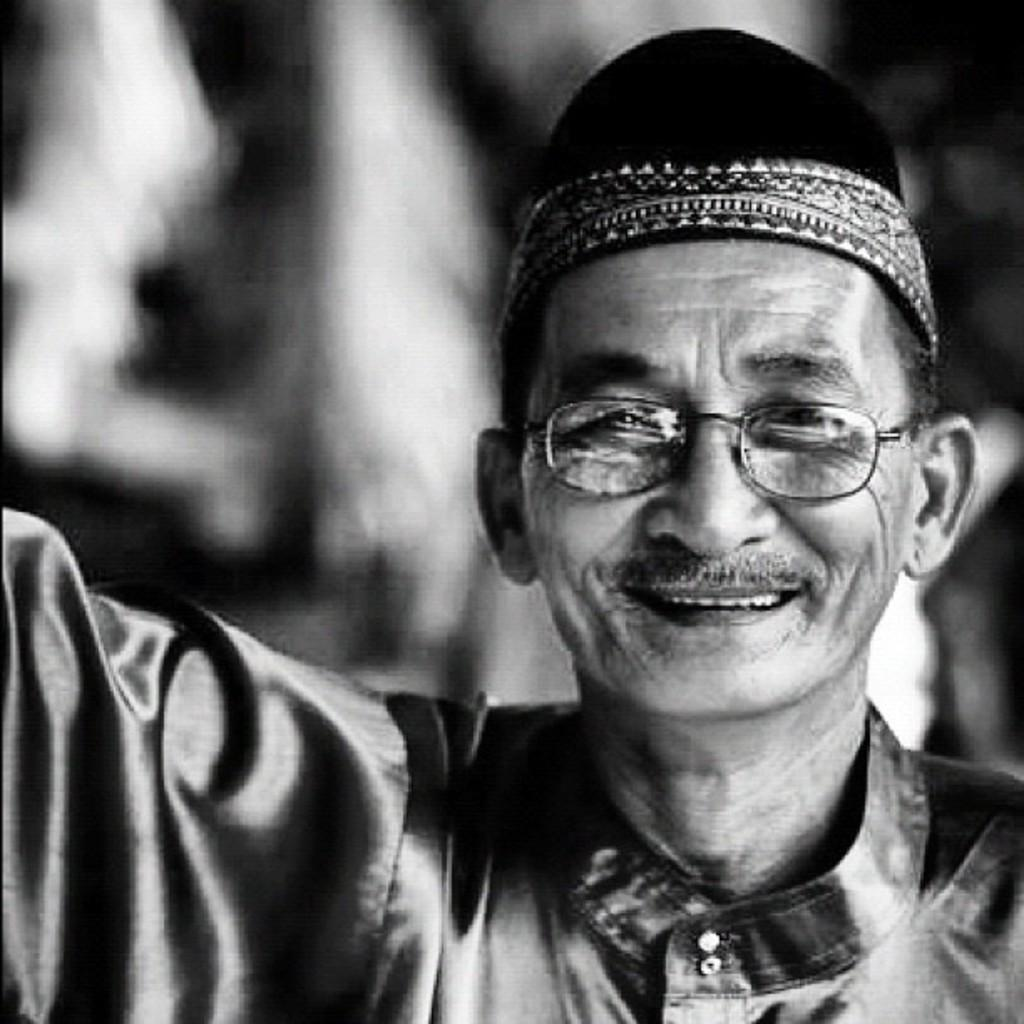Who is present in the image? There is a man in the image. On which side of the image is the man located? The man is on the right side of the image. What accessories is the man wearing? The man is wearing spectacles and a cap. What adjustments is the servant making to the man's cap in the image? There is no servant present in the image, and the man is not making any adjustments to his cap. 